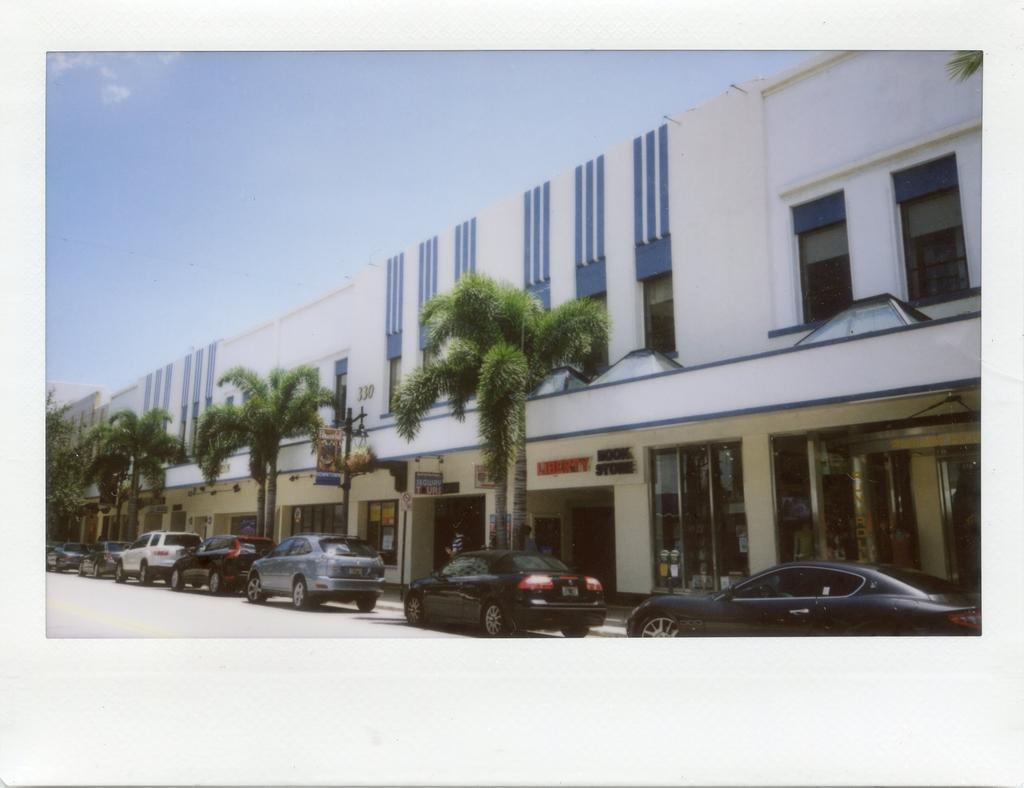How would you summarize this image in a sentence or two? In this image, we can see trees and some cars in front of the building. There is a sky at the top of the image. 